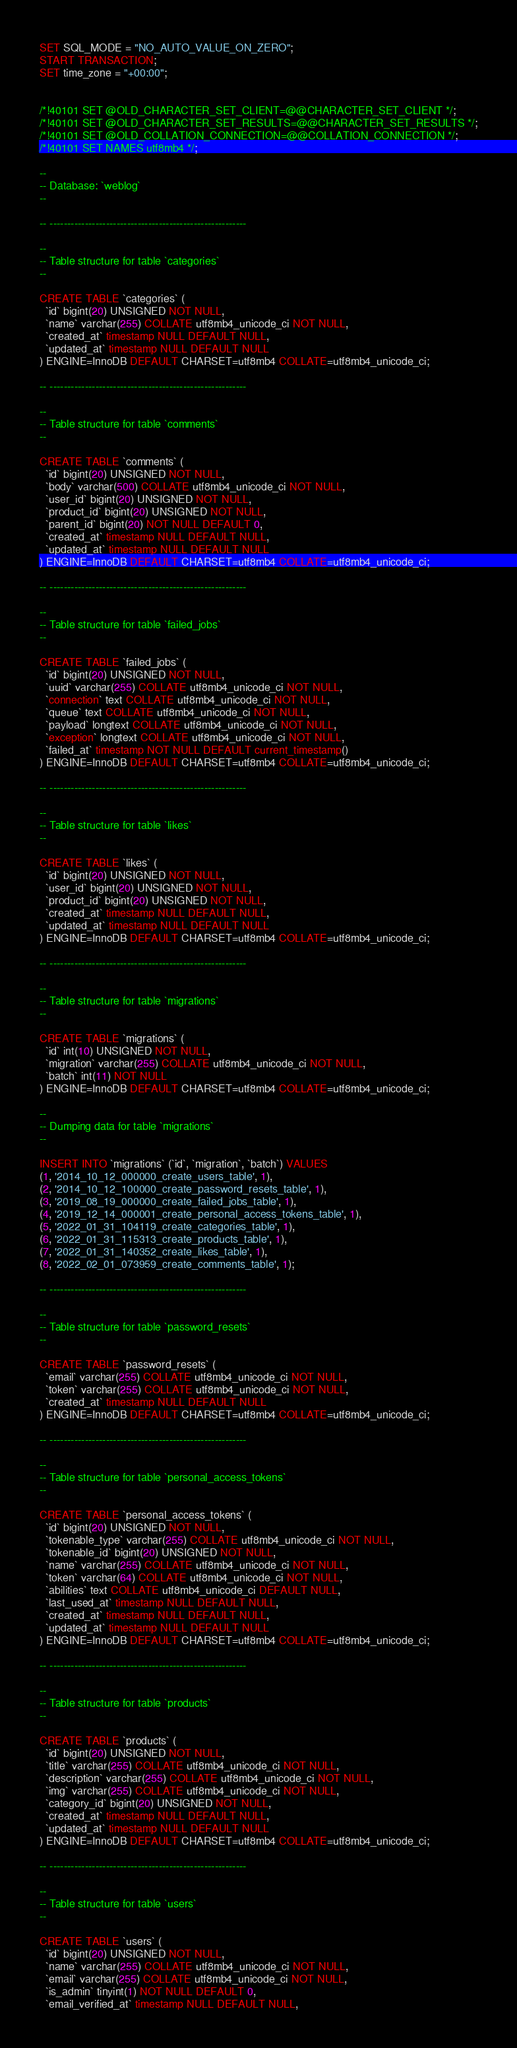<code> <loc_0><loc_0><loc_500><loc_500><_SQL_>
SET SQL_MODE = "NO_AUTO_VALUE_ON_ZERO";
START TRANSACTION;
SET time_zone = "+00:00";


/*!40101 SET @OLD_CHARACTER_SET_CLIENT=@@CHARACTER_SET_CLIENT */;
/*!40101 SET @OLD_CHARACTER_SET_RESULTS=@@CHARACTER_SET_RESULTS */;
/*!40101 SET @OLD_COLLATION_CONNECTION=@@COLLATION_CONNECTION */;
/*!40101 SET NAMES utf8mb4 */;

--
-- Database: `weblog`
--

-- --------------------------------------------------------

--
-- Table structure for table `categories`
--

CREATE TABLE `categories` (
  `id` bigint(20) UNSIGNED NOT NULL,
  `name` varchar(255) COLLATE utf8mb4_unicode_ci NOT NULL,
  `created_at` timestamp NULL DEFAULT NULL,
  `updated_at` timestamp NULL DEFAULT NULL
) ENGINE=InnoDB DEFAULT CHARSET=utf8mb4 COLLATE=utf8mb4_unicode_ci;

-- --------------------------------------------------------

--
-- Table structure for table `comments`
--

CREATE TABLE `comments` (
  `id` bigint(20) UNSIGNED NOT NULL,
  `body` varchar(500) COLLATE utf8mb4_unicode_ci NOT NULL,
  `user_id` bigint(20) UNSIGNED NOT NULL,
  `product_id` bigint(20) UNSIGNED NOT NULL,
  `parent_id` bigint(20) NOT NULL DEFAULT 0,
  `created_at` timestamp NULL DEFAULT NULL,
  `updated_at` timestamp NULL DEFAULT NULL
) ENGINE=InnoDB DEFAULT CHARSET=utf8mb4 COLLATE=utf8mb4_unicode_ci;

-- --------------------------------------------------------

--
-- Table structure for table `failed_jobs`
--

CREATE TABLE `failed_jobs` (
  `id` bigint(20) UNSIGNED NOT NULL,
  `uuid` varchar(255) COLLATE utf8mb4_unicode_ci NOT NULL,
  `connection` text COLLATE utf8mb4_unicode_ci NOT NULL,
  `queue` text COLLATE utf8mb4_unicode_ci NOT NULL,
  `payload` longtext COLLATE utf8mb4_unicode_ci NOT NULL,
  `exception` longtext COLLATE utf8mb4_unicode_ci NOT NULL,
  `failed_at` timestamp NOT NULL DEFAULT current_timestamp()
) ENGINE=InnoDB DEFAULT CHARSET=utf8mb4 COLLATE=utf8mb4_unicode_ci;

-- --------------------------------------------------------

--
-- Table structure for table `likes`
--

CREATE TABLE `likes` (
  `id` bigint(20) UNSIGNED NOT NULL,
  `user_id` bigint(20) UNSIGNED NOT NULL,
  `product_id` bigint(20) UNSIGNED NOT NULL,
  `created_at` timestamp NULL DEFAULT NULL,
  `updated_at` timestamp NULL DEFAULT NULL
) ENGINE=InnoDB DEFAULT CHARSET=utf8mb4 COLLATE=utf8mb4_unicode_ci;

-- --------------------------------------------------------

--
-- Table structure for table `migrations`
--

CREATE TABLE `migrations` (
  `id` int(10) UNSIGNED NOT NULL,
  `migration` varchar(255) COLLATE utf8mb4_unicode_ci NOT NULL,
  `batch` int(11) NOT NULL
) ENGINE=InnoDB DEFAULT CHARSET=utf8mb4 COLLATE=utf8mb4_unicode_ci;

--
-- Dumping data for table `migrations`
--

INSERT INTO `migrations` (`id`, `migration`, `batch`) VALUES
(1, '2014_10_12_000000_create_users_table', 1),
(2, '2014_10_12_100000_create_password_resets_table', 1),
(3, '2019_08_19_000000_create_failed_jobs_table', 1),
(4, '2019_12_14_000001_create_personal_access_tokens_table', 1),
(5, '2022_01_31_104119_create_categories_table', 1),
(6, '2022_01_31_115313_create_products_table', 1),
(7, '2022_01_31_140352_create_likes_table', 1),
(8, '2022_02_01_073959_create_comments_table', 1);

-- --------------------------------------------------------

--
-- Table structure for table `password_resets`
--

CREATE TABLE `password_resets` (
  `email` varchar(255) COLLATE utf8mb4_unicode_ci NOT NULL,
  `token` varchar(255) COLLATE utf8mb4_unicode_ci NOT NULL,
  `created_at` timestamp NULL DEFAULT NULL
) ENGINE=InnoDB DEFAULT CHARSET=utf8mb4 COLLATE=utf8mb4_unicode_ci;

-- --------------------------------------------------------

--
-- Table structure for table `personal_access_tokens`
--

CREATE TABLE `personal_access_tokens` (
  `id` bigint(20) UNSIGNED NOT NULL,
  `tokenable_type` varchar(255) COLLATE utf8mb4_unicode_ci NOT NULL,
  `tokenable_id` bigint(20) UNSIGNED NOT NULL,
  `name` varchar(255) COLLATE utf8mb4_unicode_ci NOT NULL,
  `token` varchar(64) COLLATE utf8mb4_unicode_ci NOT NULL,
  `abilities` text COLLATE utf8mb4_unicode_ci DEFAULT NULL,
  `last_used_at` timestamp NULL DEFAULT NULL,
  `created_at` timestamp NULL DEFAULT NULL,
  `updated_at` timestamp NULL DEFAULT NULL
) ENGINE=InnoDB DEFAULT CHARSET=utf8mb4 COLLATE=utf8mb4_unicode_ci;

-- --------------------------------------------------------

--
-- Table structure for table `products`
--

CREATE TABLE `products` (
  `id` bigint(20) UNSIGNED NOT NULL,
  `title` varchar(255) COLLATE utf8mb4_unicode_ci NOT NULL,
  `description` varchar(255) COLLATE utf8mb4_unicode_ci NOT NULL,
  `img` varchar(255) COLLATE utf8mb4_unicode_ci NOT NULL,
  `category_id` bigint(20) UNSIGNED NOT NULL,
  `created_at` timestamp NULL DEFAULT NULL,
  `updated_at` timestamp NULL DEFAULT NULL
) ENGINE=InnoDB DEFAULT CHARSET=utf8mb4 COLLATE=utf8mb4_unicode_ci;

-- --------------------------------------------------------

--
-- Table structure for table `users`
--

CREATE TABLE `users` (
  `id` bigint(20) UNSIGNED NOT NULL,
  `name` varchar(255) COLLATE utf8mb4_unicode_ci NOT NULL,
  `email` varchar(255) COLLATE utf8mb4_unicode_ci NOT NULL,
  `is_admin` tinyint(1) NOT NULL DEFAULT 0,
  `email_verified_at` timestamp NULL DEFAULT NULL,</code> 